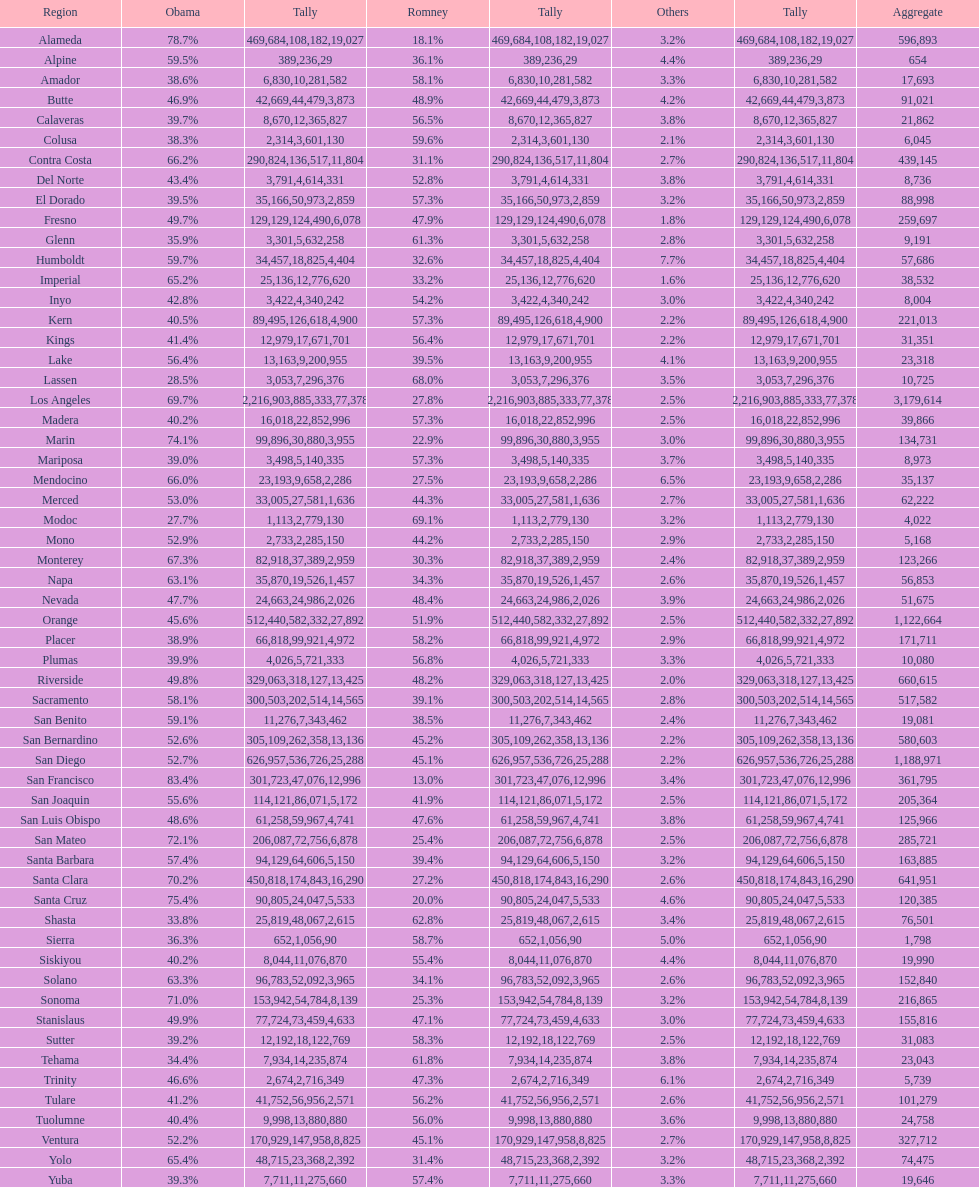What is the vote count for obama in del norte and el dorado counties? 38957. 